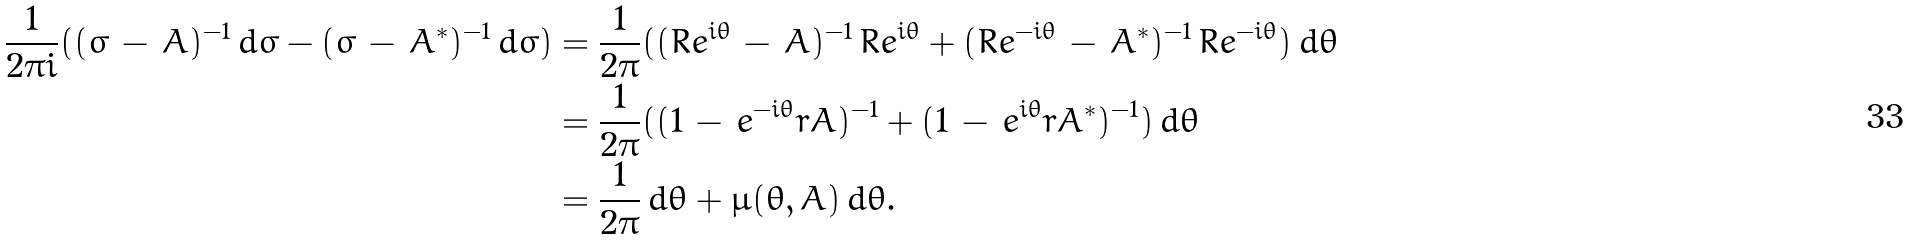Convert formula to latex. <formula><loc_0><loc_0><loc_500><loc_500>\frac { 1 } { 2 \pi i } ( ( \sigma \, - \, A ) ^ { - 1 } \, d \sigma - ( \bar { \sigma } \, - \, A ^ { * } ) ^ { - 1 } \, d \bar { \sigma } ) & = \frac { 1 } { 2 \pi } ( ( R e ^ { i \theta } \, - \, A ) ^ { - 1 } \, R e ^ { i \theta } + ( R e ^ { - i \theta } \, - \, A ^ { * } ) ^ { - 1 } \, R e ^ { - i \theta } ) \, d \theta \\ & = \frac { 1 } { 2 \pi } ( ( 1 \, - \, e ^ { - i \theta } r A ) ^ { - 1 } + ( 1 \, - \, e ^ { i \theta } r A ^ { * } ) ^ { - 1 } ) \, d \theta \\ & = \frac { 1 } { 2 \pi } \, d \theta + \mu ( \theta , A ) \, d \theta .</formula> 